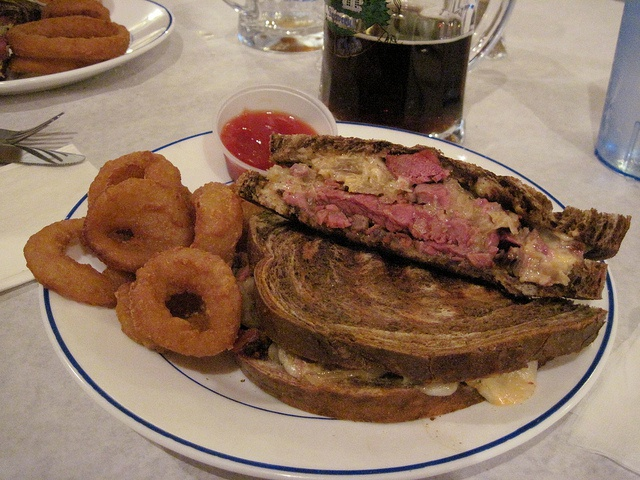Describe the objects in this image and their specific colors. I can see dining table in darkgray, tan, maroon, brown, and black tones, sandwich in black, maroon, and brown tones, cup in black, darkgray, and gray tones, donut in black, brown, and maroon tones, and donut in black, brown, and maroon tones in this image. 